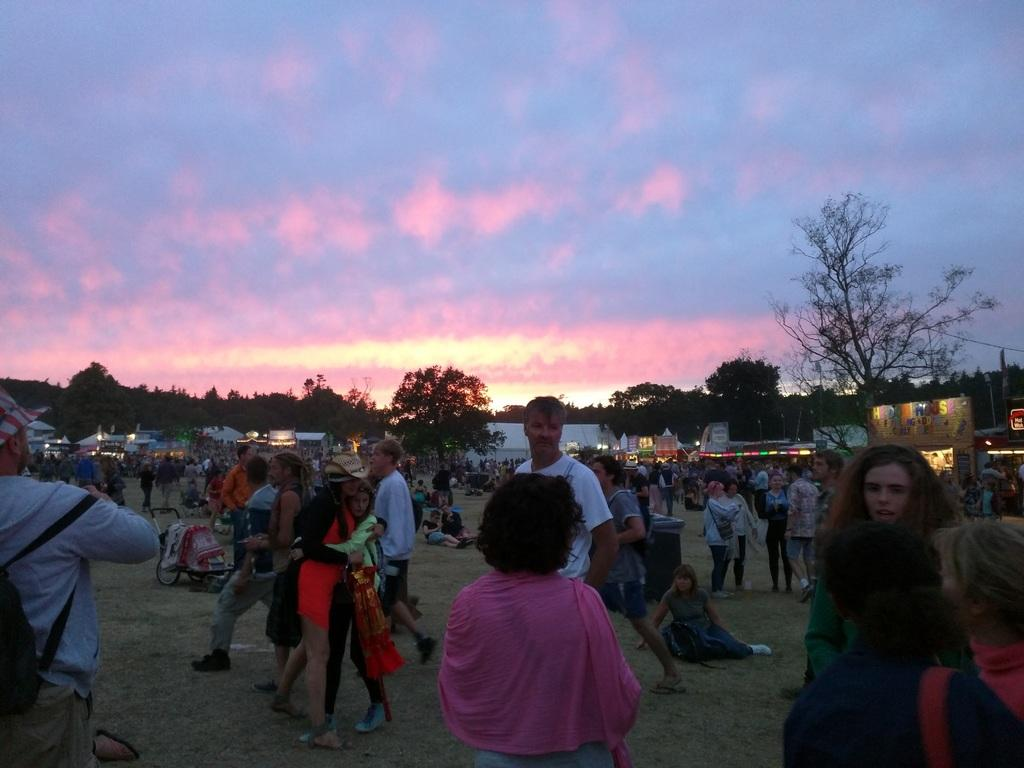How many people are in the image? There is a group of persons in the image. What are some of the people in the image doing? Some of the persons are standing on the ground, while others are sitting. What type of natural vegetation is present in the image? There are trees in the image. What can be seen in the sky in the image? The sky is visible in the image. What type of artificial light is present in the image? There is a light in the image. What is the name of the son of the person sitting on the ground in the image? There is no information about any person's son in the image, as the facts provided do not mention any names or relationships. 